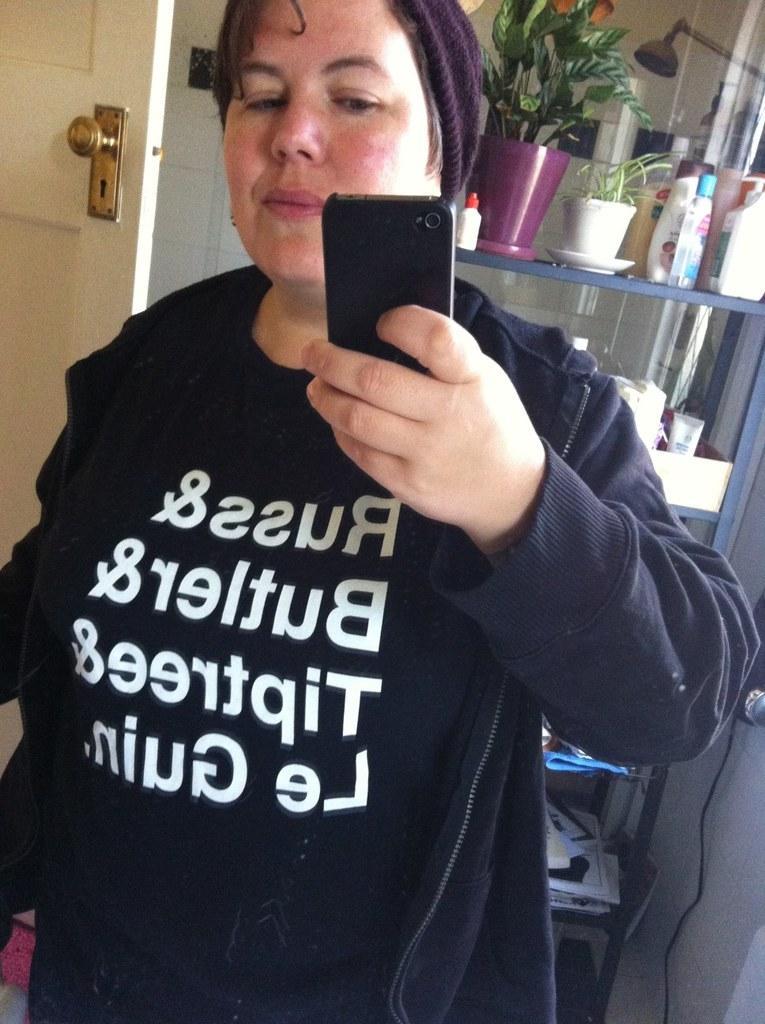Could you give a brief overview of what you see in this image? In the image there is a woman standing and taking a selfie, behind her there is a door and on the right side there are storage racks and there are shampoos, plants and other objects kept in each shelf of the storage rack. 